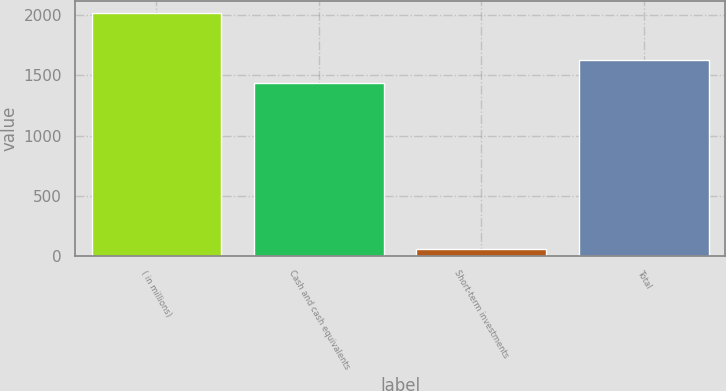Convert chart. <chart><loc_0><loc_0><loc_500><loc_500><bar_chart><fcel>( in millions)<fcel>Cash and cash equivalents<fcel>Short-term investments<fcel>Total<nl><fcel>2017<fcel>1436<fcel>55<fcel>1632.2<nl></chart> 